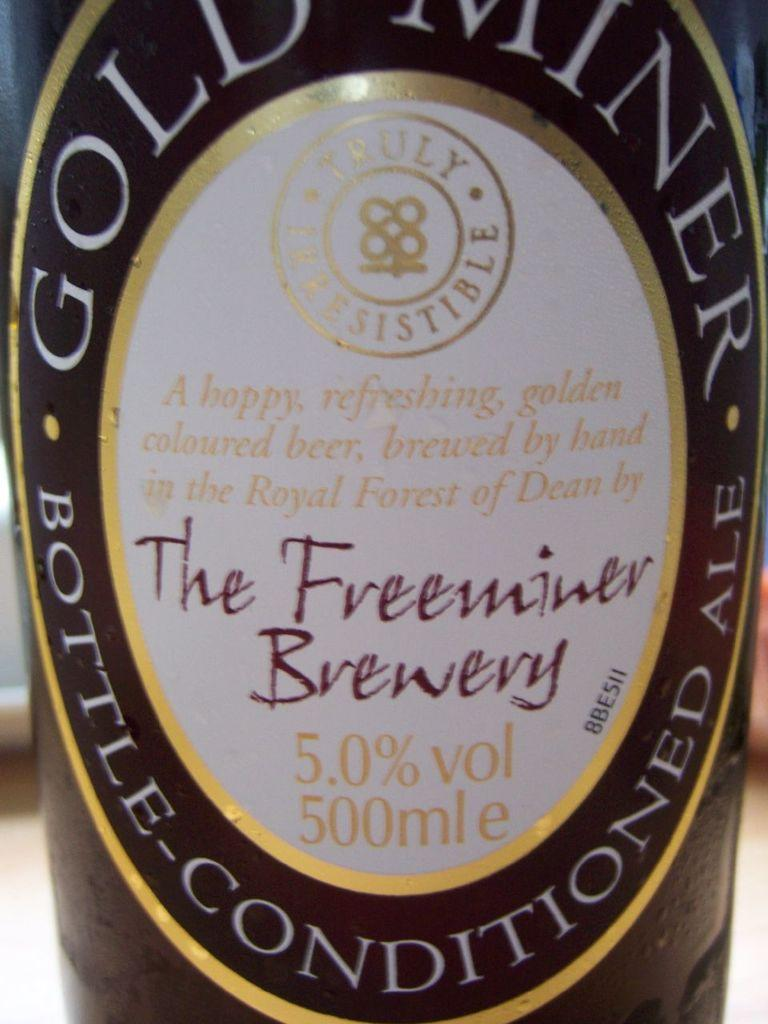Provide a one-sentence caption for the provided image. 500 ml Bottle of Bet from Gold Miner Brand from The Freeminer Brewery. 